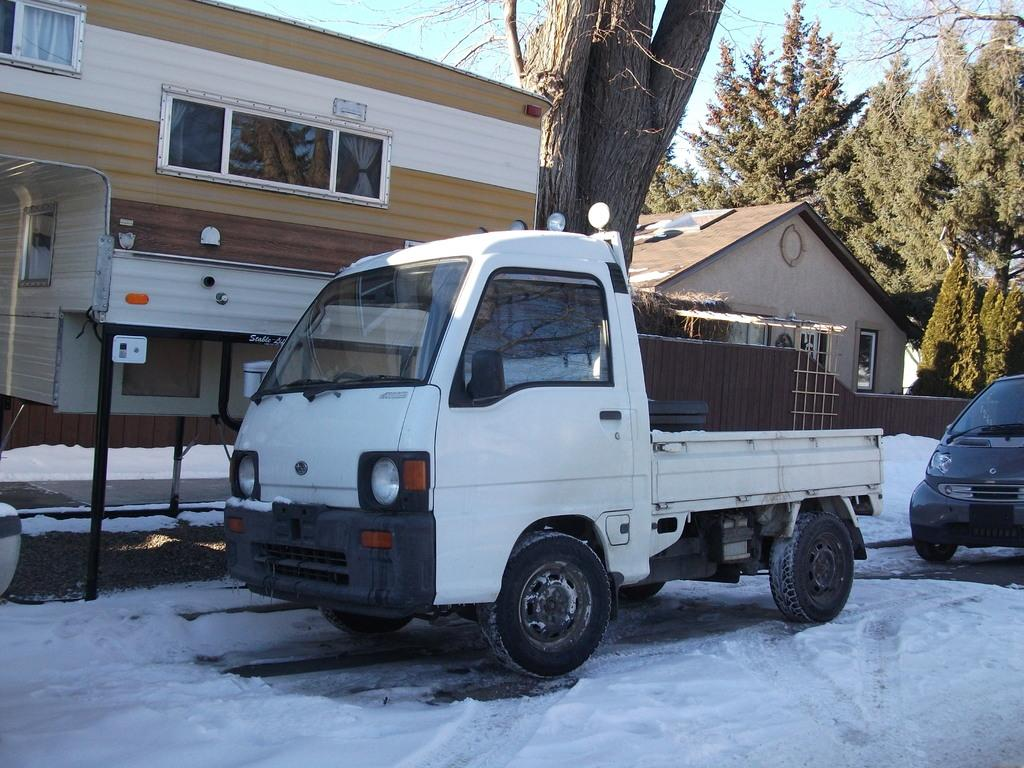What can be seen in the foreground of the image? There are two vehicles on the road in the foreground. What is present at the bottom of the image? There is snow at the bottom of the image. What can be seen in the background of the image? There is a tree trunk, two buildings, trees, and the sky visible in the background. What type of sheet is covering the vehicles in the image? There is no sheet covering the vehicles in the image; they are on the road without any covering. What authority figure can be seen in the image? There is no authority figure present in the image. 